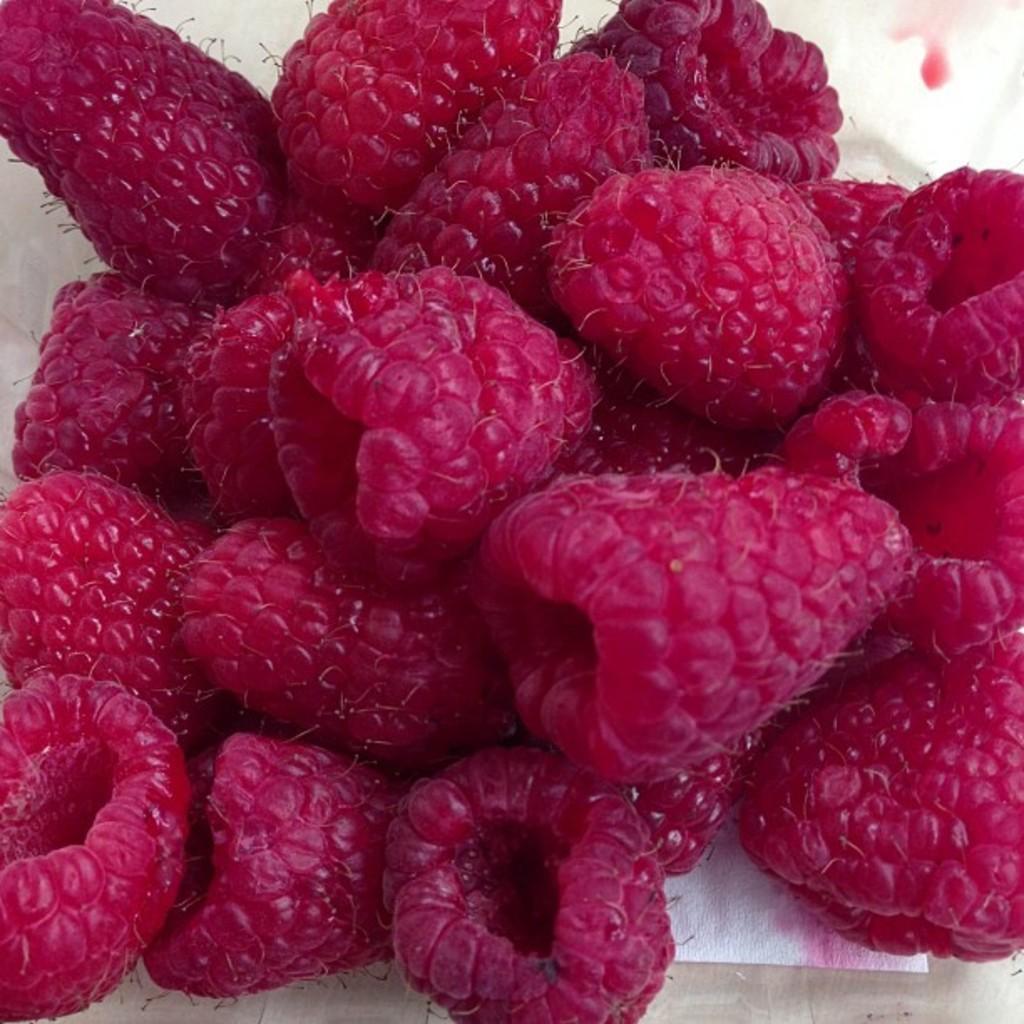In one or two sentences, can you explain what this image depicts? In this image I can see some berry on the white surface. 